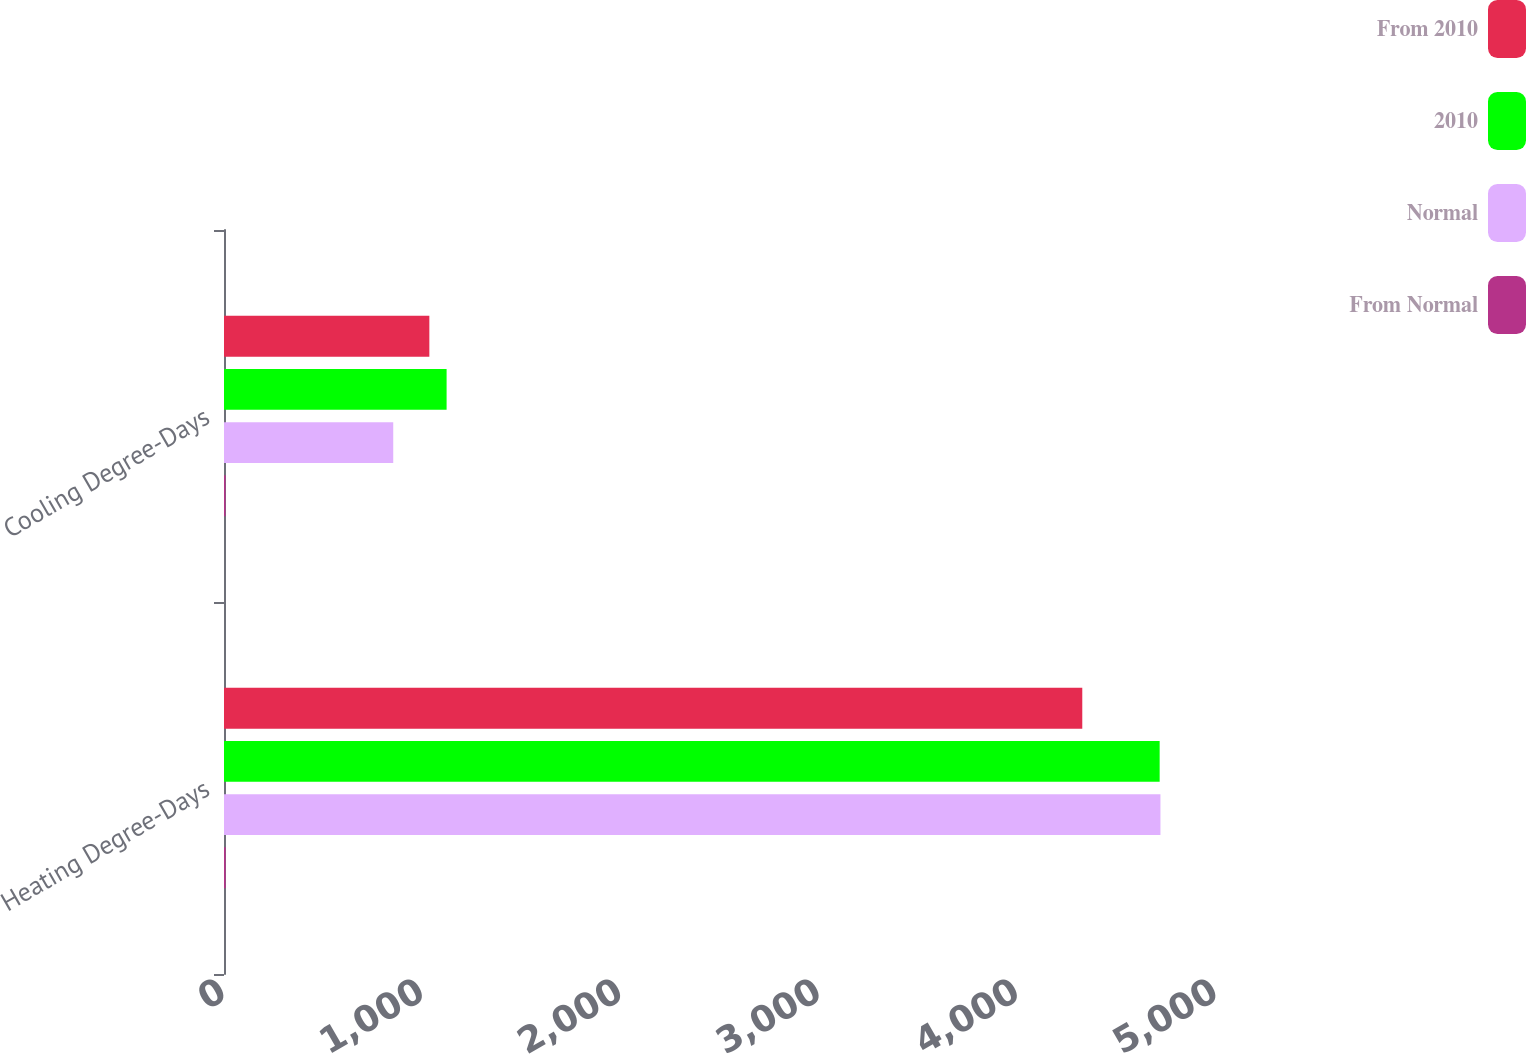<chart> <loc_0><loc_0><loc_500><loc_500><stacked_bar_chart><ecel><fcel>Heating Degree-Days<fcel>Cooling Degree-Days<nl><fcel>From 2010<fcel>4326<fcel>1035<nl><fcel>2010<fcel>4716<fcel>1122<nl><fcel>Normal<fcel>4720<fcel>853<nl><fcel>From Normal<fcel>8.3<fcel>7.8<nl></chart> 